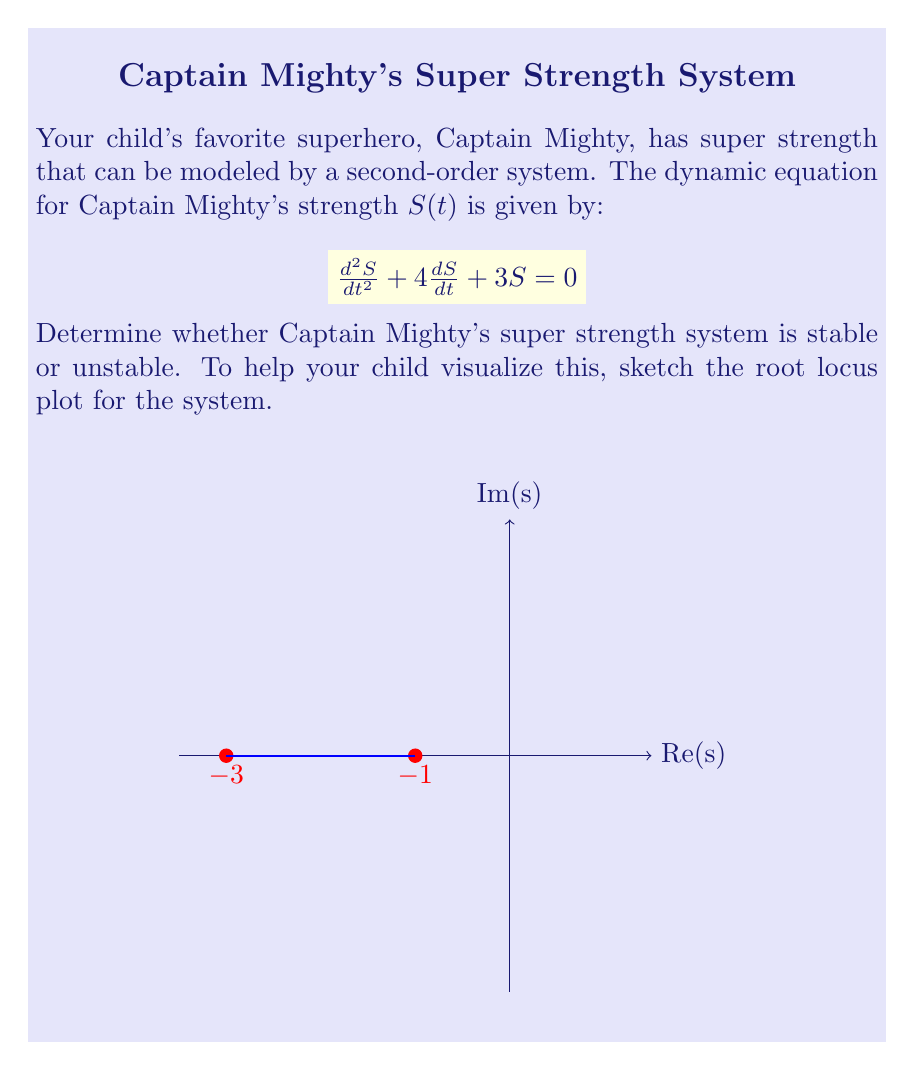Show me your answer to this math problem. Let's analyze this step-by-step:

1) The characteristic equation of the system is:
   $$s^2 + 4s + 3 = 0$$

2) To find the roots, we can factor this equation:
   $$(s + 3)(s + 1) = 0$$

3) The roots are $s_1 = -3$ and $s_2 = -1$

4) For a second-order system to be stable, both roots must have negative real parts. In this case, both roots are real and negative.

5) The root locus plot shows both roots on the negative real axis:
   - One root at $s = -3$
   - One root at $s = -1$

6) Since both roots are in the left half of the s-plane (negative real parts), the system is stable.

7) Physically, this means that if Captain Mighty's strength is disturbed from its equilibrium state, it will naturally return to that state over time, rather than growing uncontrollably or oscillating indefinitely.

8) The fact that both roots are real and negative also indicates that the system is overdamped, meaning Captain Mighty's strength will return to equilibrium without oscillating.
Answer: Stable 